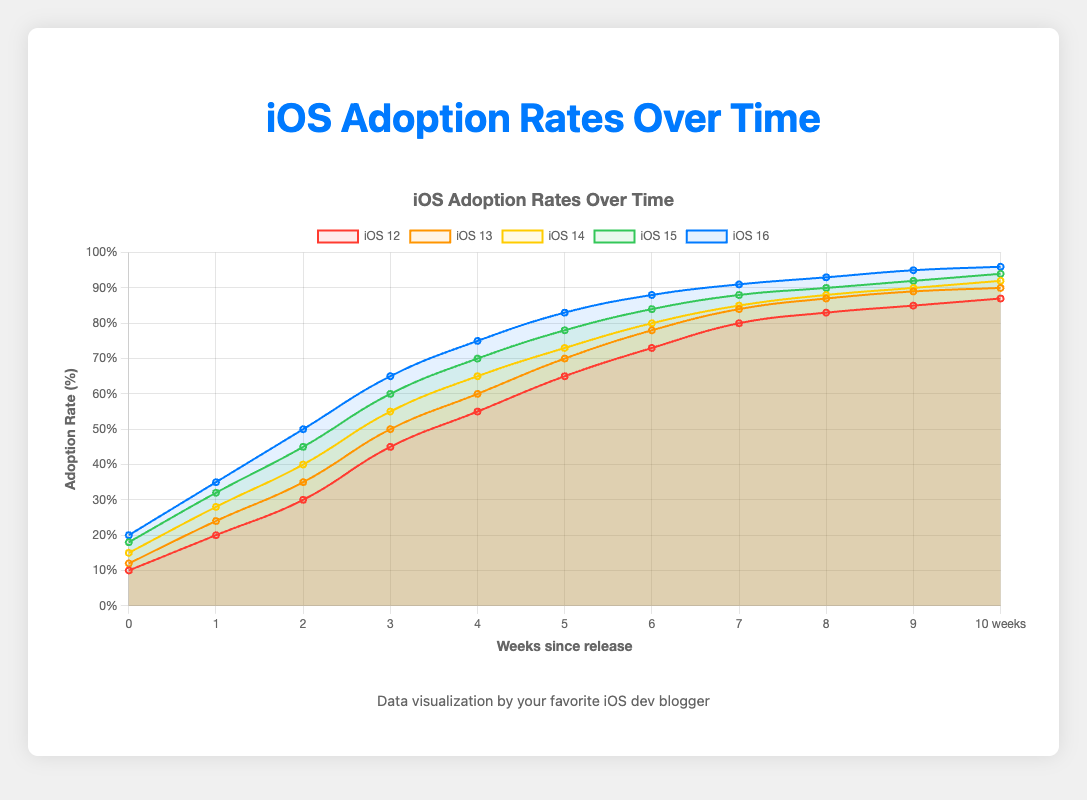What's the final adoption rate of iOS 13? To find the final adoption rate for iOS 13, look at the last data point for the iOS 13 line, which corresponds to the adoption rate at 20 weeks.
Answer: 90% Comparing iOS 14 and iOS 15, which one has a higher adoption rate at 10 weeks? For this, compare the adoption rates of iOS 14 and iOS 15 at the 10-week mark from their respective lines on the chart. iOS 14 shows 73%, while iOS 15 shows 78%.
Answer: iOS 15 What is the average adoption rate of iOS 16 over the first 4 weeks? Add the adoption rates for iOS 16 at weeks 1, 2, 4, and 6 (20%, 35%, 50%, and 65%) and divide by 4: (20+35+50+65)/4.
Answer: 42.5% Which iOS version had the fastest initial adoption rate in the first week? Look at the initial adoption rates (at week 1) for all iOS versions. iOS 16 has the highest value, 20%.
Answer: iOS 16 By how many percentage points does the adoption rate of iOS 12 increase between week 4 and week 8? Subtract the adoption rate at week 4 from the rate at week 8 for iOS 12: 55% - 30%.
Answer: 25% Which version shows the smallest increase in adoption rates between week 10 and week 20? Compare the adoption rates at week 10 and week 20 for all versions: 
iOS 12: 87% - 65% = 22%
iOS 13: 90% - 70% = 20%
iOS 14: 92% - 73% = 19%
iOS 15: 94% - 78% = 16%
iOS 16: 96% - 83% = 13% 
iOS 16 shows the smallest increase at 13%.
Answer: iOS 16 Out of iOS 12, 13, and 14, which version reached an 80% adoption rate the fastest, and how long did it take? Identify the week where each version reaches 80%: 
iOS 12: 14 weeks, 
iOS 13: 14 weeks, 
iOS 14: 14 weeks.
All three reached 80% adoption rate at the same time: 14 weeks.
Answer: 14 weeks What's the total increase in the adoption rate for iOS 15 from week 1 to week 20? Subtract the adoption rate at week 1 from the rate at week 20 for iOS 15: 94% - 18%.
Answer: 76% How does the adoption rate of iOS 15 at week 12 compare to iOS 14 at the same point? Compare the adoption rates of both versions at the 12-week mark: iOS 15 is 84%, and iOS 14 is 80%.
Answer: iOS 15 has a higher rate 